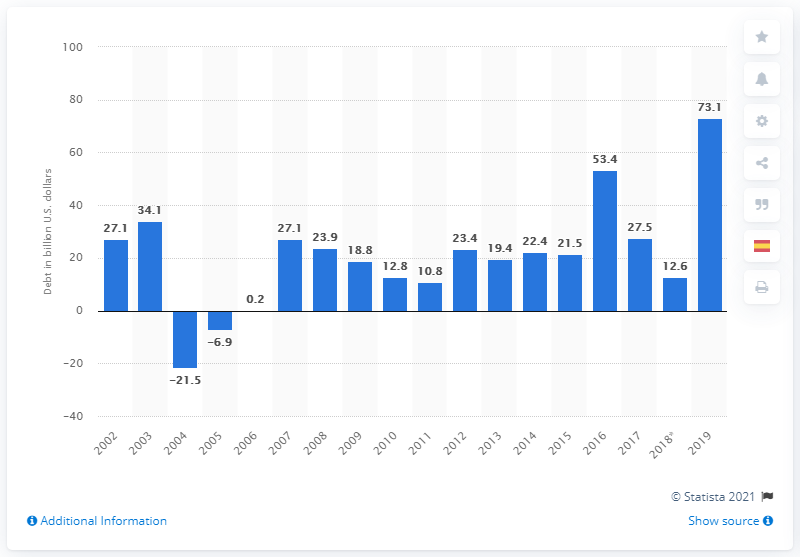Outline some significant characteristics in this image. In 2019, the long-term debt of U.S. shareholder-owned electric utilities increased by approximately $73.1 billion. 